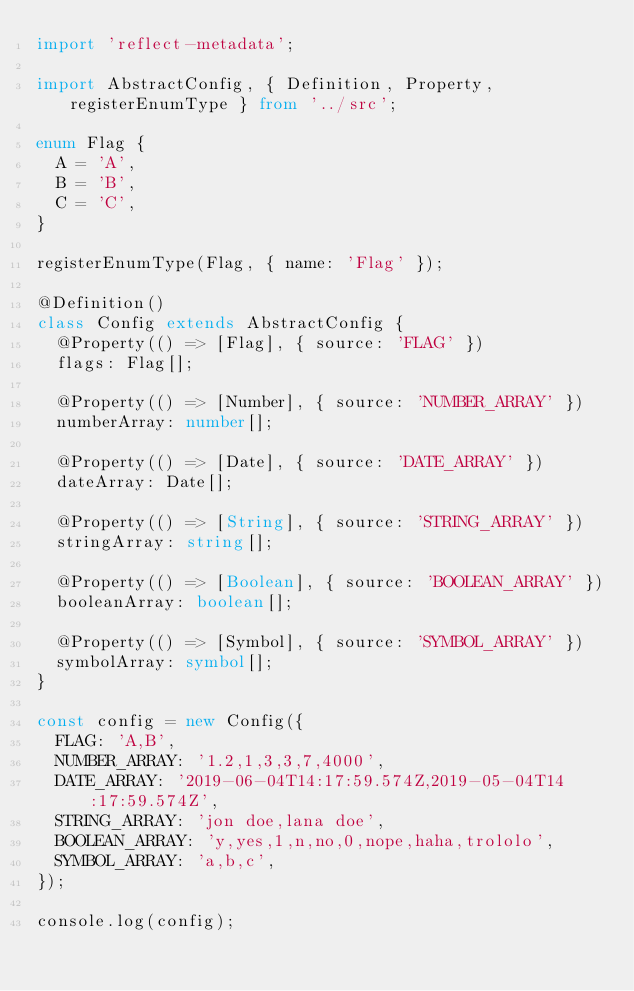Convert code to text. <code><loc_0><loc_0><loc_500><loc_500><_TypeScript_>import 'reflect-metadata';

import AbstractConfig, { Definition, Property, registerEnumType } from '../src';

enum Flag {
  A = 'A',
  B = 'B',
  C = 'C',
}

registerEnumType(Flag, { name: 'Flag' });

@Definition()
class Config extends AbstractConfig {
  @Property(() => [Flag], { source: 'FLAG' })
  flags: Flag[];

  @Property(() => [Number], { source: 'NUMBER_ARRAY' })
  numberArray: number[];

  @Property(() => [Date], { source: 'DATE_ARRAY' })
  dateArray: Date[];

  @Property(() => [String], { source: 'STRING_ARRAY' })
  stringArray: string[];

  @Property(() => [Boolean], { source: 'BOOLEAN_ARRAY' })
  booleanArray: boolean[];

  @Property(() => [Symbol], { source: 'SYMBOL_ARRAY' })
  symbolArray: symbol[];
}

const config = new Config({
  FLAG: 'A,B',
  NUMBER_ARRAY: '1.2,1,3,3,7,4000',
  DATE_ARRAY: '2019-06-04T14:17:59.574Z,2019-05-04T14:17:59.574Z',
  STRING_ARRAY: 'jon doe,lana doe',
  BOOLEAN_ARRAY: 'y,yes,1,n,no,0,nope,haha,trololo',
  SYMBOL_ARRAY: 'a,b,c',
});

console.log(config);
</code> 